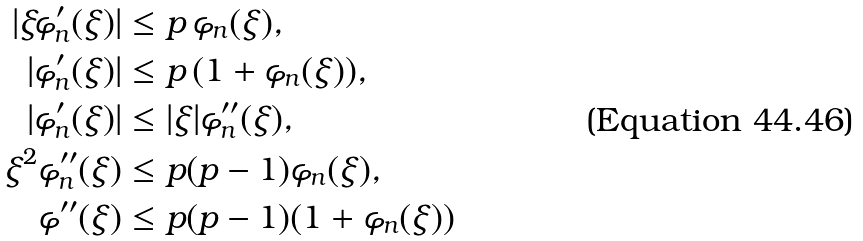<formula> <loc_0><loc_0><loc_500><loc_500>| \xi \varphi ^ { \prime } _ { n } ( \xi ) | & \leq p \, \varphi _ { n } ( \xi ) , \\ | \varphi ^ { \prime } _ { n } ( \xi ) | & \leq p \, ( 1 + \varphi _ { n } ( \xi ) ) , \\ | \varphi ^ { \prime } _ { n } ( \xi ) | & \leq | \xi | \varphi ^ { \prime \prime } _ { n } ( \xi ) , \\ \xi ^ { 2 } \varphi ^ { \prime \prime } _ { n } ( \xi ) & \leq p ( p - 1 ) \varphi _ { n } ( \xi ) , \\ \varphi ^ { \prime \prime } ( \xi ) & \leq p ( p - 1 ) ( 1 + \varphi _ { n } ( \xi ) )</formula> 